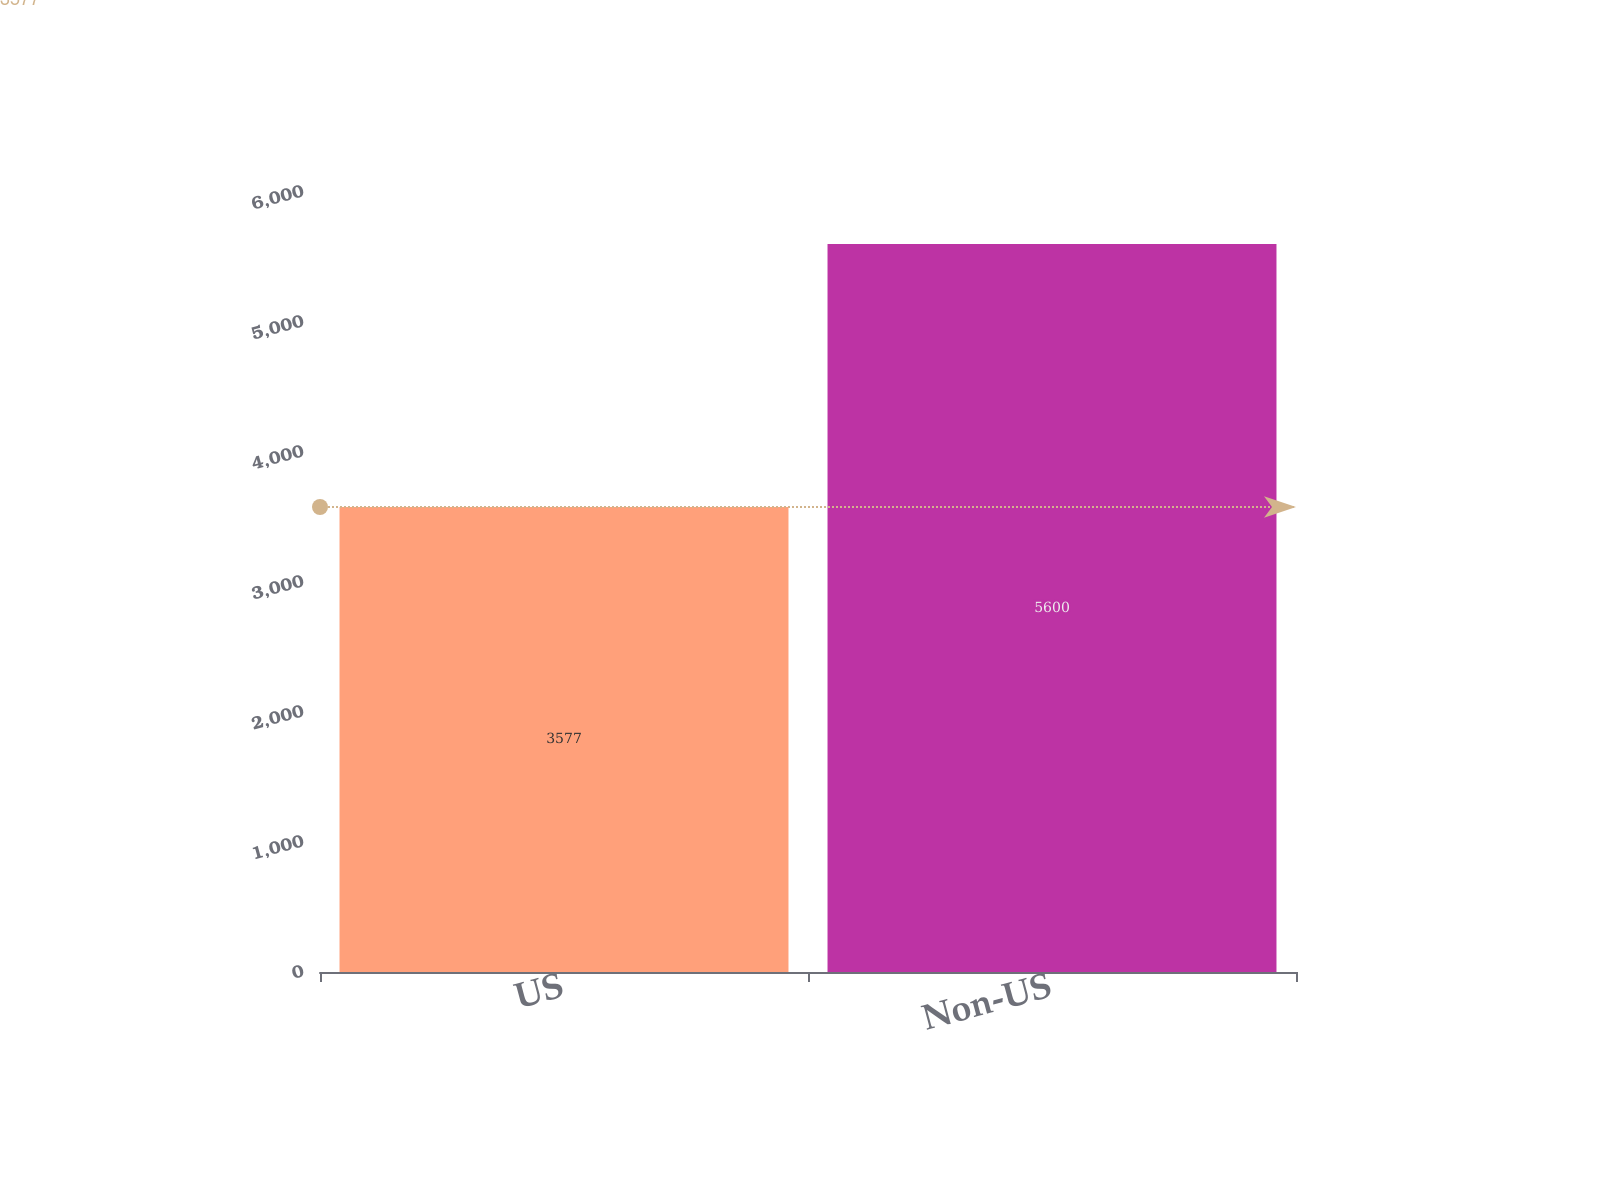<chart> <loc_0><loc_0><loc_500><loc_500><bar_chart><fcel>US<fcel>Non-US<nl><fcel>3577<fcel>5600<nl></chart> 